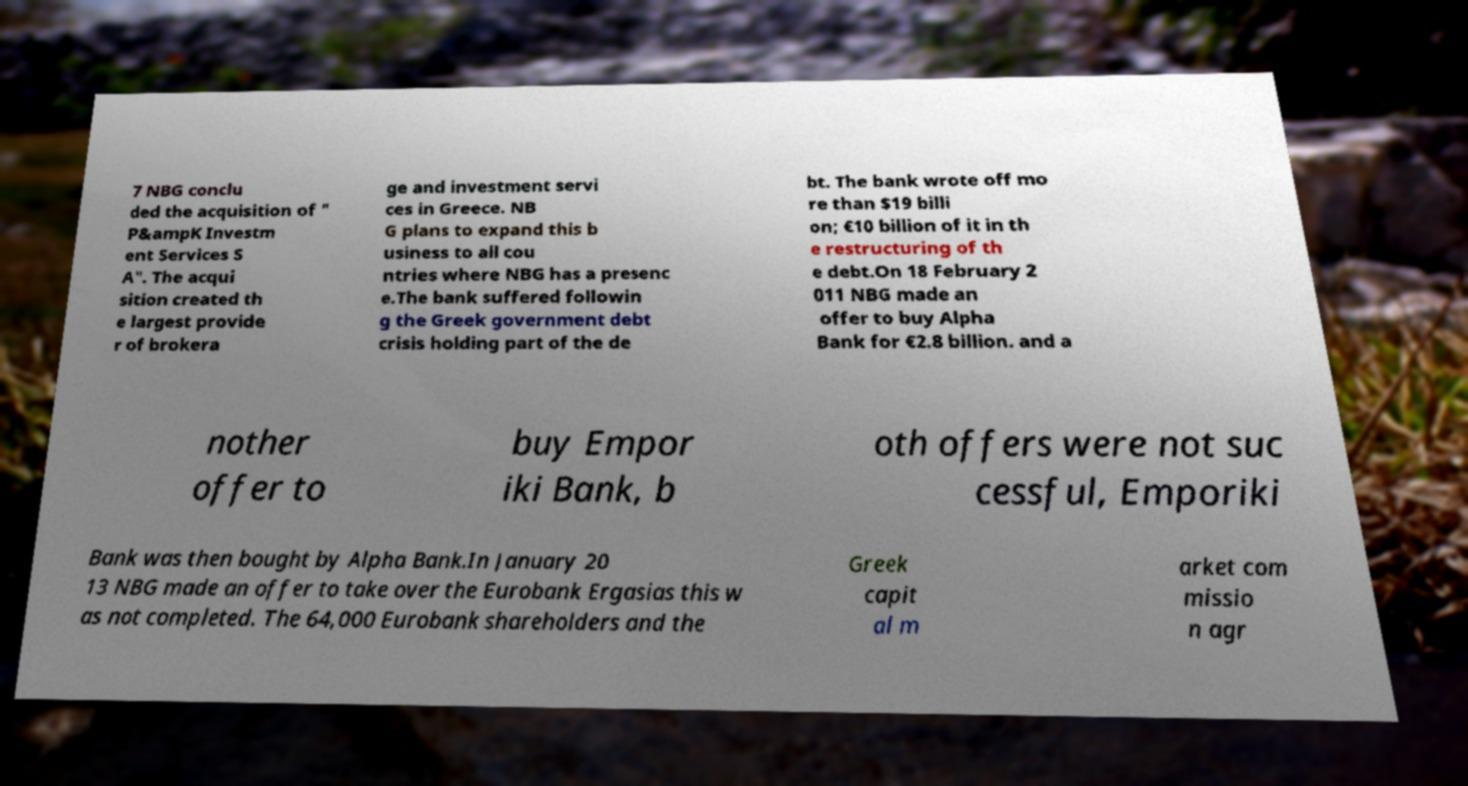I need the written content from this picture converted into text. Can you do that? 7 NBG conclu ded the acquisition of " P&ampK Investm ent Services S A". The acqui sition created th e largest provide r of brokera ge and investment servi ces in Greece. NB G plans to expand this b usiness to all cou ntries where NBG has a presenc e.The bank suffered followin g the Greek government debt crisis holding part of the de bt. The bank wrote off mo re than $19 billi on; €10 billion of it in th e restructuring of th e debt.On 18 February 2 011 NBG made an offer to buy Alpha Bank for €2.8 billion. and a nother offer to buy Empor iki Bank, b oth offers were not suc cessful, Emporiki Bank was then bought by Alpha Bank.In January 20 13 NBG made an offer to take over the Eurobank Ergasias this w as not completed. The 64,000 Eurobank shareholders and the Greek capit al m arket com missio n agr 